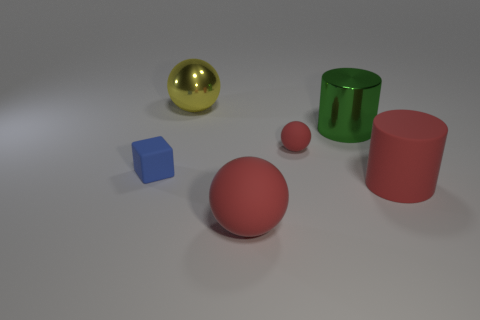Add 4 big red shiny cylinders. How many objects exist? 10 Subtract all cylinders. How many objects are left? 4 Subtract all big purple rubber objects. Subtract all yellow metallic balls. How many objects are left? 5 Add 6 small balls. How many small balls are left? 7 Add 1 cyan blocks. How many cyan blocks exist? 1 Subtract 0 purple cylinders. How many objects are left? 6 